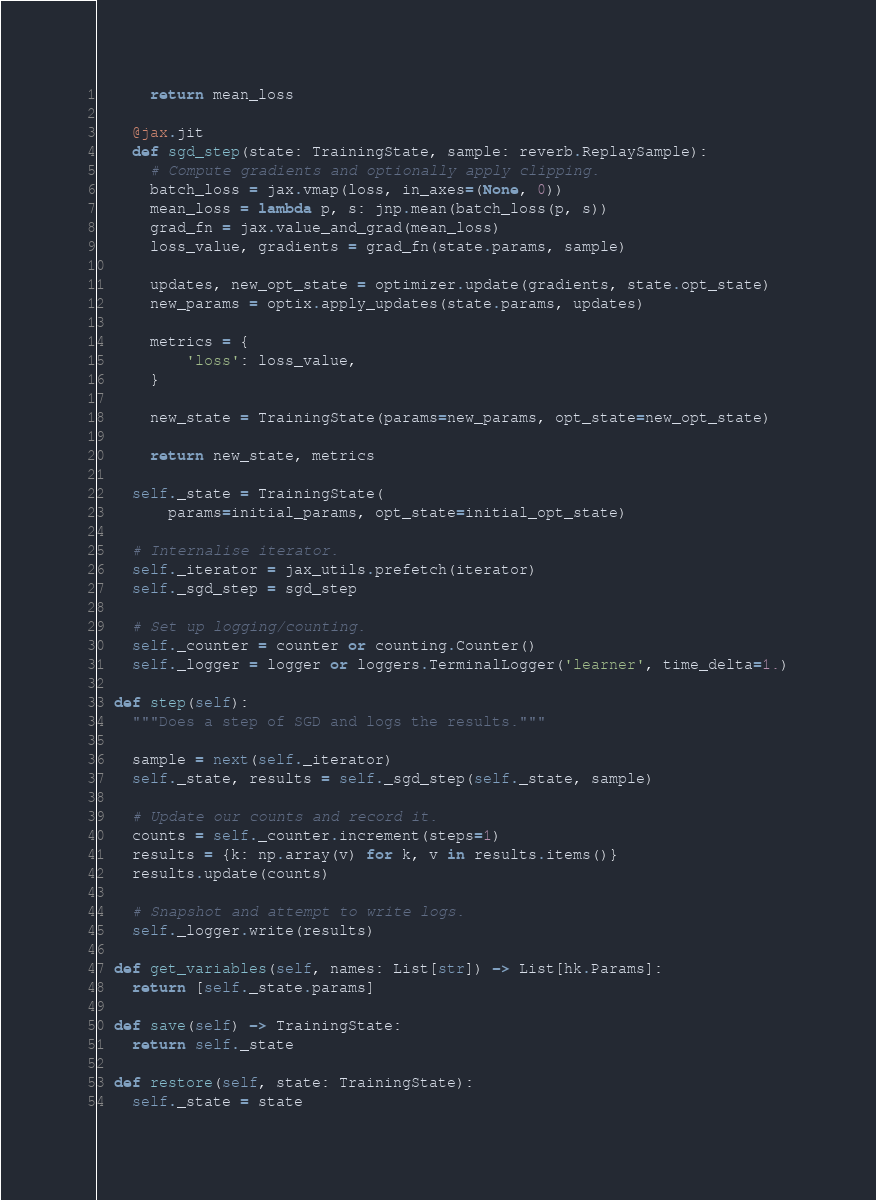<code> <loc_0><loc_0><loc_500><loc_500><_Python_>
      return mean_loss

    @jax.jit
    def sgd_step(state: TrainingState, sample: reverb.ReplaySample):
      # Compute gradients and optionally apply clipping.
      batch_loss = jax.vmap(loss, in_axes=(None, 0))
      mean_loss = lambda p, s: jnp.mean(batch_loss(p, s))
      grad_fn = jax.value_and_grad(mean_loss)
      loss_value, gradients = grad_fn(state.params, sample)

      updates, new_opt_state = optimizer.update(gradients, state.opt_state)
      new_params = optix.apply_updates(state.params, updates)

      metrics = {
          'loss': loss_value,
      }

      new_state = TrainingState(params=new_params, opt_state=new_opt_state)

      return new_state, metrics

    self._state = TrainingState(
        params=initial_params, opt_state=initial_opt_state)

    # Internalise iterator.
    self._iterator = jax_utils.prefetch(iterator)
    self._sgd_step = sgd_step

    # Set up logging/counting.
    self._counter = counter or counting.Counter()
    self._logger = logger or loggers.TerminalLogger('learner', time_delta=1.)

  def step(self):
    """Does a step of SGD and logs the results."""

    sample = next(self._iterator)
    self._state, results = self._sgd_step(self._state, sample)

    # Update our counts and record it.
    counts = self._counter.increment(steps=1)
    results = {k: np.array(v) for k, v in results.items()}
    results.update(counts)

    # Snapshot and attempt to write logs.
    self._logger.write(results)

  def get_variables(self, names: List[str]) -> List[hk.Params]:
    return [self._state.params]

  def save(self) -> TrainingState:
    return self._state

  def restore(self, state: TrainingState):
    self._state = state
</code> 